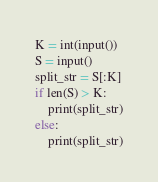<code> <loc_0><loc_0><loc_500><loc_500><_Python_>K = int(input())
S = input()
split_str = S[:K]
if len(S) > K:
    print(split_str)
else:
    print(split_str)</code> 